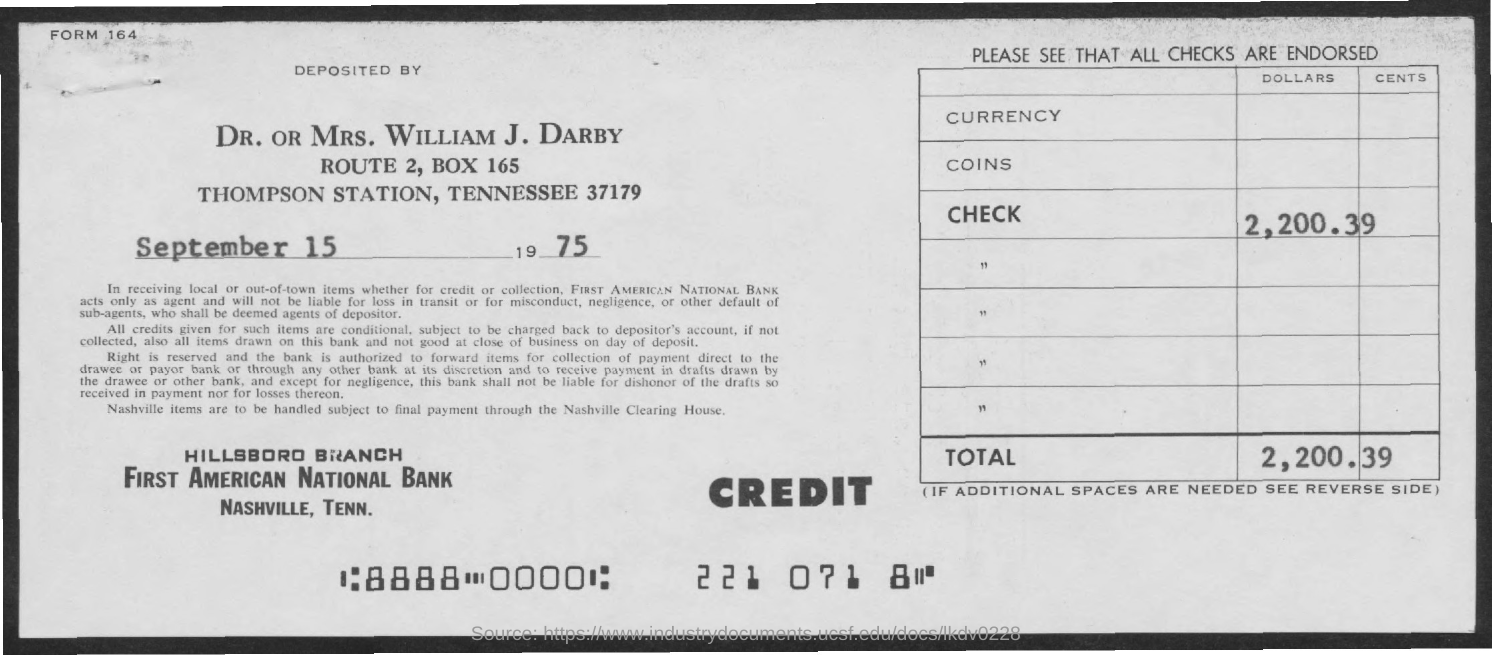Mention a couple of crucial points in this snapshot. The Form No mentioned in the document is Form 164. The amount of the check is $2,200.39. The deposit date as specified in the document is September 15, 1975. The document indicates that William J. Darby has deposited the check amount. 